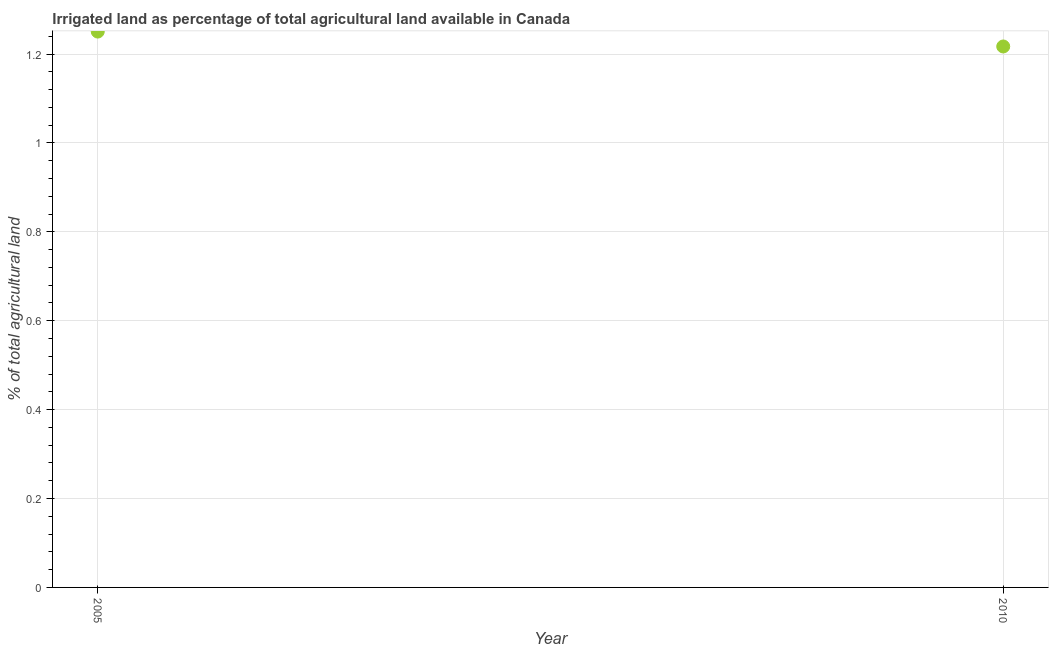What is the percentage of agricultural irrigated land in 2010?
Offer a terse response. 1.22. Across all years, what is the maximum percentage of agricultural irrigated land?
Offer a very short reply. 1.25. Across all years, what is the minimum percentage of agricultural irrigated land?
Provide a succinct answer. 1.22. In which year was the percentage of agricultural irrigated land maximum?
Your answer should be very brief. 2005. What is the sum of the percentage of agricultural irrigated land?
Your response must be concise. 2.47. What is the difference between the percentage of agricultural irrigated land in 2005 and 2010?
Your response must be concise. 0.03. What is the average percentage of agricultural irrigated land per year?
Your answer should be very brief. 1.23. What is the median percentage of agricultural irrigated land?
Your response must be concise. 1.23. What is the ratio of the percentage of agricultural irrigated land in 2005 to that in 2010?
Make the answer very short. 1.03. In how many years, is the percentage of agricultural irrigated land greater than the average percentage of agricultural irrigated land taken over all years?
Make the answer very short. 1. What is the difference between two consecutive major ticks on the Y-axis?
Keep it short and to the point. 0.2. Are the values on the major ticks of Y-axis written in scientific E-notation?
Keep it short and to the point. No. Does the graph contain any zero values?
Provide a succinct answer. No. What is the title of the graph?
Your answer should be very brief. Irrigated land as percentage of total agricultural land available in Canada. What is the label or title of the X-axis?
Your response must be concise. Year. What is the label or title of the Y-axis?
Ensure brevity in your answer.  % of total agricultural land. What is the % of total agricultural land in 2005?
Your answer should be very brief. 1.25. What is the % of total agricultural land in 2010?
Your answer should be very brief. 1.22. What is the difference between the % of total agricultural land in 2005 and 2010?
Make the answer very short. 0.03. What is the ratio of the % of total agricultural land in 2005 to that in 2010?
Your response must be concise. 1.03. 